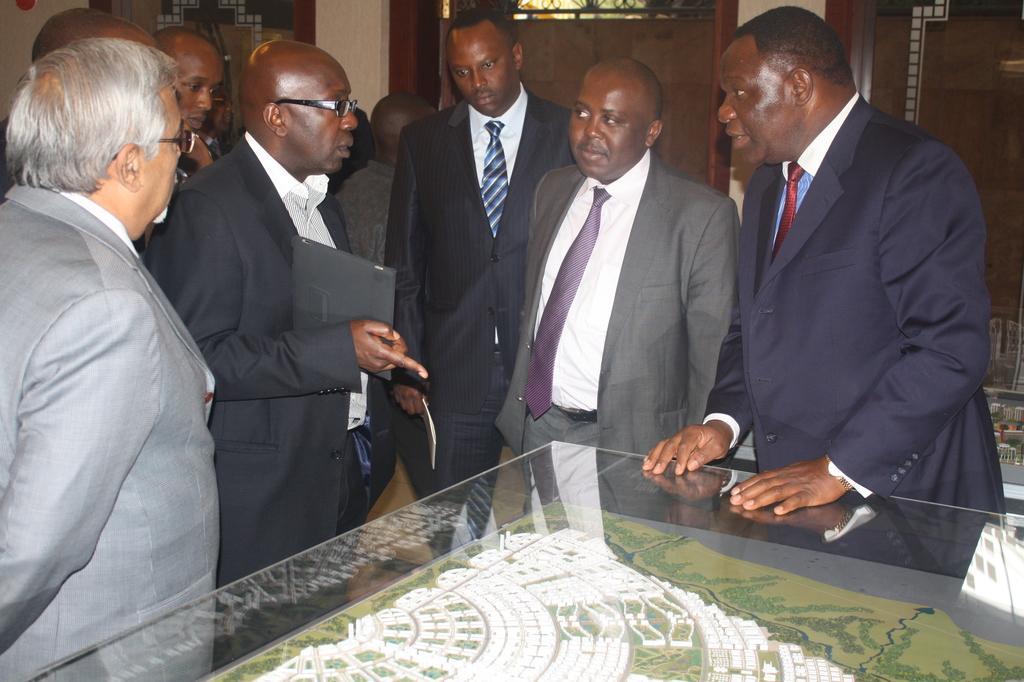How would you summarize this image in a sentence or two? In this image I can see some people standing around the table, behind that there are some doors in the middle of wall. 